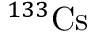<formula> <loc_0><loc_0><loc_500><loc_500>^ { 1 3 3 } C s</formula> 